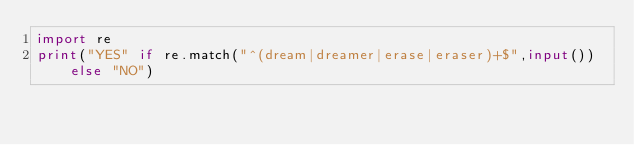<code> <loc_0><loc_0><loc_500><loc_500><_Python_>import re
print("YES" if re.match("^(dream|dreamer|erase|eraser)+$",input()) else "NO")</code> 